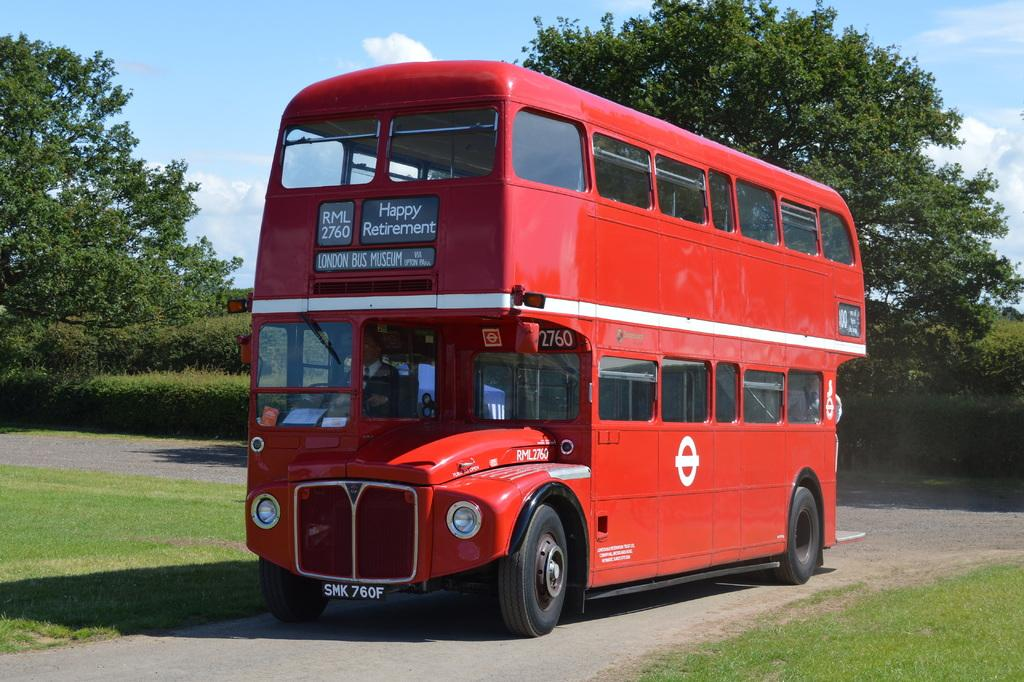<image>
Give a short and clear explanation of the subsequent image. London Bus Museum is displayed on the front of this double deck bus. 